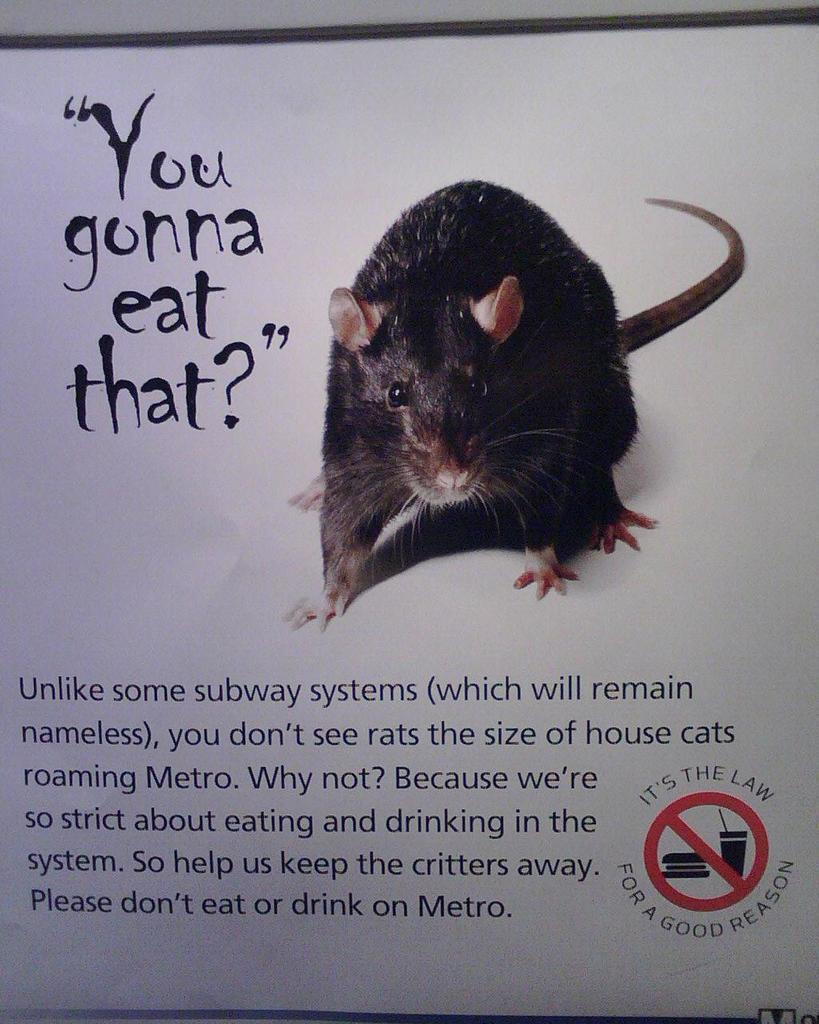What is the main subject of the image? The main subject of the image is a photo of a rat. What else can be seen in the image besides the photo of the rat? There is something written on a white color board in the image. What type of paint is being used to create the produce in the image? There is no paint, produce, or pipe present in the image. 